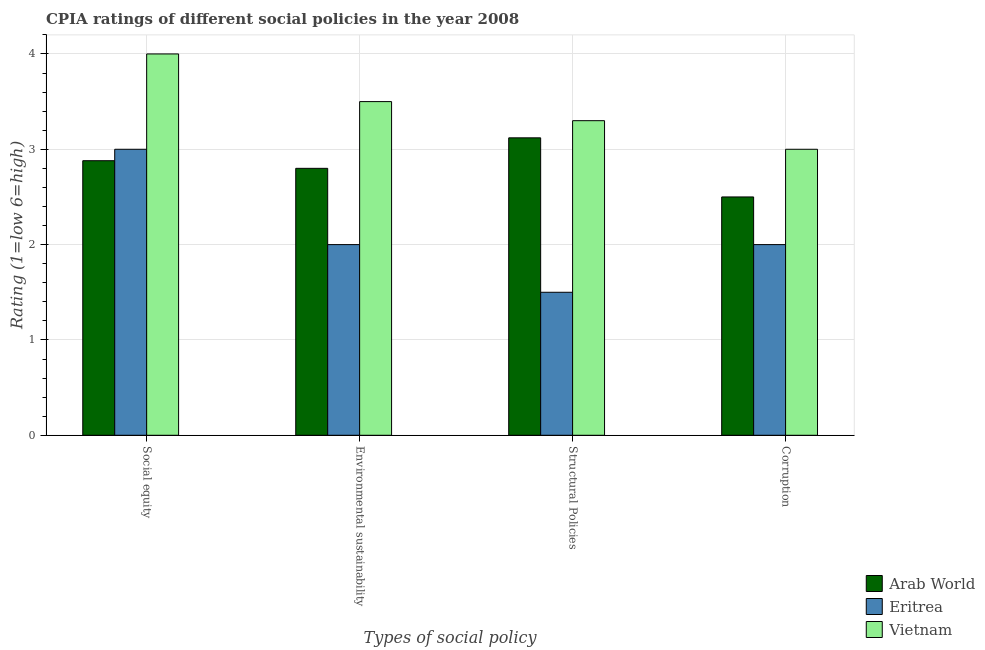How many different coloured bars are there?
Ensure brevity in your answer.  3. How many groups of bars are there?
Make the answer very short. 4. What is the label of the 4th group of bars from the left?
Offer a terse response. Corruption. What is the cpia rating of corruption in Vietnam?
Give a very brief answer. 3. Across all countries, what is the maximum cpia rating of environmental sustainability?
Your answer should be very brief. 3.5. Across all countries, what is the minimum cpia rating of social equity?
Provide a short and direct response. 2.88. In which country was the cpia rating of structural policies maximum?
Your response must be concise. Vietnam. In which country was the cpia rating of structural policies minimum?
Your answer should be very brief. Eritrea. What is the total cpia rating of corruption in the graph?
Your answer should be very brief. 7.5. What is the difference between the cpia rating of social equity in Vietnam and that in Arab World?
Keep it short and to the point. 1.12. What is the difference between the cpia rating of social equity in Vietnam and the cpia rating of structural policies in Arab World?
Keep it short and to the point. 0.88. What is the average cpia rating of social equity per country?
Your answer should be compact. 3.29. What is the difference between the cpia rating of environmental sustainability and cpia rating of structural policies in Arab World?
Your answer should be compact. -0.32. In how many countries, is the cpia rating of corruption greater than 3 ?
Ensure brevity in your answer.  0. What is the ratio of the cpia rating of corruption in Eritrea to that in Vietnam?
Ensure brevity in your answer.  0.67. What is the difference between the highest and the lowest cpia rating of structural policies?
Offer a terse response. 1.8. In how many countries, is the cpia rating of social equity greater than the average cpia rating of social equity taken over all countries?
Your response must be concise. 1. Is the sum of the cpia rating of corruption in Arab World and Vietnam greater than the maximum cpia rating of social equity across all countries?
Your response must be concise. Yes. Is it the case that in every country, the sum of the cpia rating of structural policies and cpia rating of environmental sustainability is greater than the sum of cpia rating of social equity and cpia rating of corruption?
Provide a short and direct response. No. What does the 2nd bar from the left in Social equity represents?
Provide a short and direct response. Eritrea. What does the 1st bar from the right in Structural Policies represents?
Your answer should be compact. Vietnam. Is it the case that in every country, the sum of the cpia rating of social equity and cpia rating of environmental sustainability is greater than the cpia rating of structural policies?
Keep it short and to the point. Yes. How many countries are there in the graph?
Offer a terse response. 3. What is the difference between two consecutive major ticks on the Y-axis?
Your response must be concise. 1. Are the values on the major ticks of Y-axis written in scientific E-notation?
Keep it short and to the point. No. Does the graph contain any zero values?
Provide a short and direct response. No. How many legend labels are there?
Your response must be concise. 3. How are the legend labels stacked?
Make the answer very short. Vertical. What is the title of the graph?
Provide a succinct answer. CPIA ratings of different social policies in the year 2008. Does "Kazakhstan" appear as one of the legend labels in the graph?
Offer a very short reply. No. What is the label or title of the X-axis?
Offer a very short reply. Types of social policy. What is the label or title of the Y-axis?
Your answer should be very brief. Rating (1=low 6=high). What is the Rating (1=low 6=high) of Arab World in Social equity?
Ensure brevity in your answer.  2.88. What is the Rating (1=low 6=high) of Eritrea in Social equity?
Provide a succinct answer. 3. What is the Rating (1=low 6=high) in Eritrea in Environmental sustainability?
Provide a succinct answer. 2. What is the Rating (1=low 6=high) of Vietnam in Environmental sustainability?
Your answer should be compact. 3.5. What is the Rating (1=low 6=high) of Arab World in Structural Policies?
Make the answer very short. 3.12. What is the Rating (1=low 6=high) of Vietnam in Structural Policies?
Your answer should be very brief. 3.3. What is the Rating (1=low 6=high) of Arab World in Corruption?
Make the answer very short. 2.5. What is the Rating (1=low 6=high) of Eritrea in Corruption?
Offer a terse response. 2. What is the Rating (1=low 6=high) of Vietnam in Corruption?
Your response must be concise. 3. Across all Types of social policy, what is the maximum Rating (1=low 6=high) in Arab World?
Provide a short and direct response. 3.12. Across all Types of social policy, what is the maximum Rating (1=low 6=high) in Eritrea?
Offer a very short reply. 3. Across all Types of social policy, what is the maximum Rating (1=low 6=high) of Vietnam?
Provide a succinct answer. 4. Across all Types of social policy, what is the minimum Rating (1=low 6=high) in Arab World?
Give a very brief answer. 2.5. Across all Types of social policy, what is the minimum Rating (1=low 6=high) in Eritrea?
Offer a very short reply. 1.5. Across all Types of social policy, what is the minimum Rating (1=low 6=high) in Vietnam?
Offer a terse response. 3. What is the difference between the Rating (1=low 6=high) of Arab World in Social equity and that in Structural Policies?
Keep it short and to the point. -0.24. What is the difference between the Rating (1=low 6=high) of Eritrea in Social equity and that in Structural Policies?
Your response must be concise. 1.5. What is the difference between the Rating (1=low 6=high) in Arab World in Social equity and that in Corruption?
Keep it short and to the point. 0.38. What is the difference between the Rating (1=low 6=high) in Eritrea in Social equity and that in Corruption?
Give a very brief answer. 1. What is the difference between the Rating (1=low 6=high) in Arab World in Environmental sustainability and that in Structural Policies?
Make the answer very short. -0.32. What is the difference between the Rating (1=low 6=high) of Eritrea in Environmental sustainability and that in Structural Policies?
Provide a succinct answer. 0.5. What is the difference between the Rating (1=low 6=high) of Vietnam in Environmental sustainability and that in Corruption?
Your answer should be very brief. 0.5. What is the difference between the Rating (1=low 6=high) of Arab World in Structural Policies and that in Corruption?
Your answer should be very brief. 0.62. What is the difference between the Rating (1=low 6=high) of Eritrea in Structural Policies and that in Corruption?
Give a very brief answer. -0.5. What is the difference between the Rating (1=low 6=high) of Arab World in Social equity and the Rating (1=low 6=high) of Vietnam in Environmental sustainability?
Ensure brevity in your answer.  -0.62. What is the difference between the Rating (1=low 6=high) of Arab World in Social equity and the Rating (1=low 6=high) of Eritrea in Structural Policies?
Offer a terse response. 1.38. What is the difference between the Rating (1=low 6=high) in Arab World in Social equity and the Rating (1=low 6=high) in Vietnam in Structural Policies?
Keep it short and to the point. -0.42. What is the difference between the Rating (1=low 6=high) of Arab World in Social equity and the Rating (1=low 6=high) of Vietnam in Corruption?
Your answer should be compact. -0.12. What is the difference between the Rating (1=low 6=high) in Arab World in Environmental sustainability and the Rating (1=low 6=high) in Eritrea in Structural Policies?
Give a very brief answer. 1.3. What is the difference between the Rating (1=low 6=high) of Arab World in Environmental sustainability and the Rating (1=low 6=high) of Vietnam in Structural Policies?
Offer a terse response. -0.5. What is the difference between the Rating (1=low 6=high) in Eritrea in Environmental sustainability and the Rating (1=low 6=high) in Vietnam in Structural Policies?
Ensure brevity in your answer.  -1.3. What is the difference between the Rating (1=low 6=high) of Arab World in Environmental sustainability and the Rating (1=low 6=high) of Vietnam in Corruption?
Offer a terse response. -0.2. What is the difference between the Rating (1=low 6=high) in Arab World in Structural Policies and the Rating (1=low 6=high) in Eritrea in Corruption?
Keep it short and to the point. 1.12. What is the difference between the Rating (1=low 6=high) of Arab World in Structural Policies and the Rating (1=low 6=high) of Vietnam in Corruption?
Your answer should be compact. 0.12. What is the difference between the Rating (1=low 6=high) of Eritrea in Structural Policies and the Rating (1=low 6=high) of Vietnam in Corruption?
Ensure brevity in your answer.  -1.5. What is the average Rating (1=low 6=high) of Arab World per Types of social policy?
Your response must be concise. 2.83. What is the average Rating (1=low 6=high) in Eritrea per Types of social policy?
Your answer should be very brief. 2.12. What is the average Rating (1=low 6=high) in Vietnam per Types of social policy?
Offer a terse response. 3.45. What is the difference between the Rating (1=low 6=high) of Arab World and Rating (1=low 6=high) of Eritrea in Social equity?
Ensure brevity in your answer.  -0.12. What is the difference between the Rating (1=low 6=high) in Arab World and Rating (1=low 6=high) in Vietnam in Social equity?
Your response must be concise. -1.12. What is the difference between the Rating (1=low 6=high) of Eritrea and Rating (1=low 6=high) of Vietnam in Social equity?
Keep it short and to the point. -1. What is the difference between the Rating (1=low 6=high) in Eritrea and Rating (1=low 6=high) in Vietnam in Environmental sustainability?
Offer a very short reply. -1.5. What is the difference between the Rating (1=low 6=high) in Arab World and Rating (1=low 6=high) in Eritrea in Structural Policies?
Your answer should be very brief. 1.62. What is the difference between the Rating (1=low 6=high) in Arab World and Rating (1=low 6=high) in Vietnam in Structural Policies?
Your response must be concise. -0.18. What is the ratio of the Rating (1=low 6=high) of Arab World in Social equity to that in Environmental sustainability?
Keep it short and to the point. 1.03. What is the ratio of the Rating (1=low 6=high) in Vietnam in Social equity to that in Environmental sustainability?
Offer a terse response. 1.14. What is the ratio of the Rating (1=low 6=high) of Eritrea in Social equity to that in Structural Policies?
Provide a succinct answer. 2. What is the ratio of the Rating (1=low 6=high) of Vietnam in Social equity to that in Structural Policies?
Keep it short and to the point. 1.21. What is the ratio of the Rating (1=low 6=high) of Arab World in Social equity to that in Corruption?
Give a very brief answer. 1.15. What is the ratio of the Rating (1=low 6=high) of Arab World in Environmental sustainability to that in Structural Policies?
Your response must be concise. 0.9. What is the ratio of the Rating (1=low 6=high) in Eritrea in Environmental sustainability to that in Structural Policies?
Ensure brevity in your answer.  1.33. What is the ratio of the Rating (1=low 6=high) in Vietnam in Environmental sustainability to that in Structural Policies?
Provide a short and direct response. 1.06. What is the ratio of the Rating (1=low 6=high) of Arab World in Environmental sustainability to that in Corruption?
Make the answer very short. 1.12. What is the ratio of the Rating (1=low 6=high) of Vietnam in Environmental sustainability to that in Corruption?
Provide a short and direct response. 1.17. What is the ratio of the Rating (1=low 6=high) of Arab World in Structural Policies to that in Corruption?
Make the answer very short. 1.25. What is the ratio of the Rating (1=low 6=high) of Eritrea in Structural Policies to that in Corruption?
Offer a terse response. 0.75. What is the difference between the highest and the second highest Rating (1=low 6=high) of Arab World?
Keep it short and to the point. 0.24. What is the difference between the highest and the lowest Rating (1=low 6=high) in Arab World?
Give a very brief answer. 0.62. What is the difference between the highest and the lowest Rating (1=low 6=high) in Eritrea?
Your answer should be very brief. 1.5. 